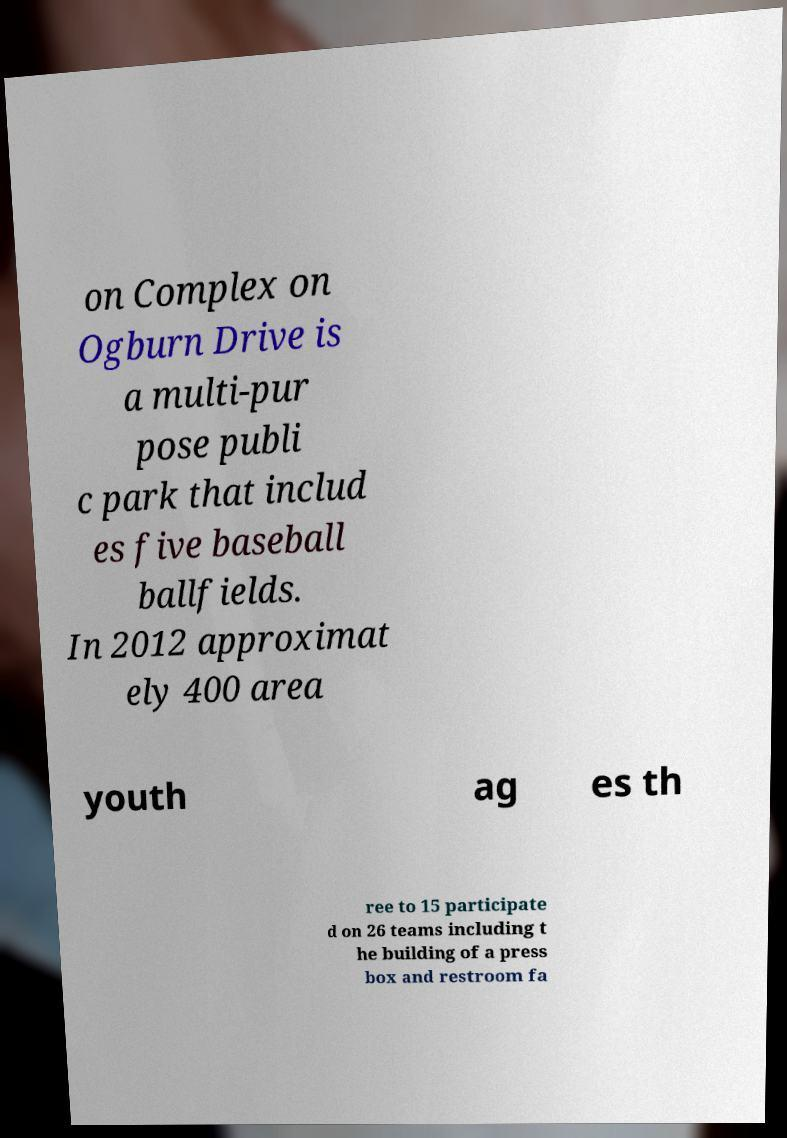Can you read and provide the text displayed in the image?This photo seems to have some interesting text. Can you extract and type it out for me? on Complex on Ogburn Drive is a multi-pur pose publi c park that includ es five baseball ballfields. In 2012 approximat ely 400 area youth ag es th ree to 15 participate d on 26 teams including t he building of a press box and restroom fa 